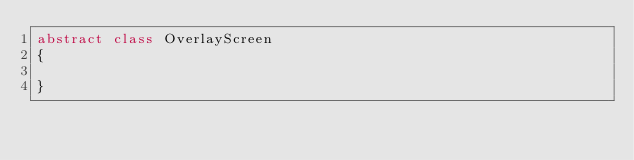<code> <loc_0><loc_0><loc_500><loc_500><_Kotlin_>abstract class OverlayScreen
{

}</code> 